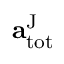<formula> <loc_0><loc_0><loc_500><loc_500>a _ { t o t } ^ { J }</formula> 